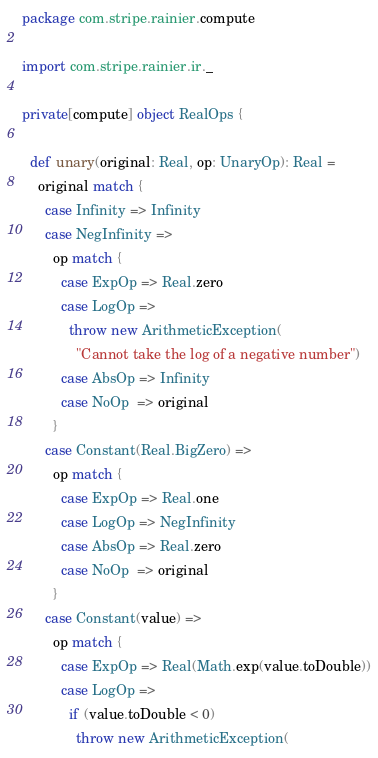Convert code to text. <code><loc_0><loc_0><loc_500><loc_500><_Scala_>package com.stripe.rainier.compute

import com.stripe.rainier.ir._

private[compute] object RealOps {

  def unary(original: Real, op: UnaryOp): Real =
    original match {
      case Infinity => Infinity
      case NegInfinity =>
        op match {
          case ExpOp => Real.zero
          case LogOp =>
            throw new ArithmeticException(
              "Cannot take the log of a negative number")
          case AbsOp => Infinity
          case NoOp  => original
        }
      case Constant(Real.BigZero) =>
        op match {
          case ExpOp => Real.one
          case LogOp => NegInfinity
          case AbsOp => Real.zero
          case NoOp  => original
        }
      case Constant(value) =>
        op match {
          case ExpOp => Real(Math.exp(value.toDouble))
          case LogOp =>
            if (value.toDouble < 0)
              throw new ArithmeticException(</code> 